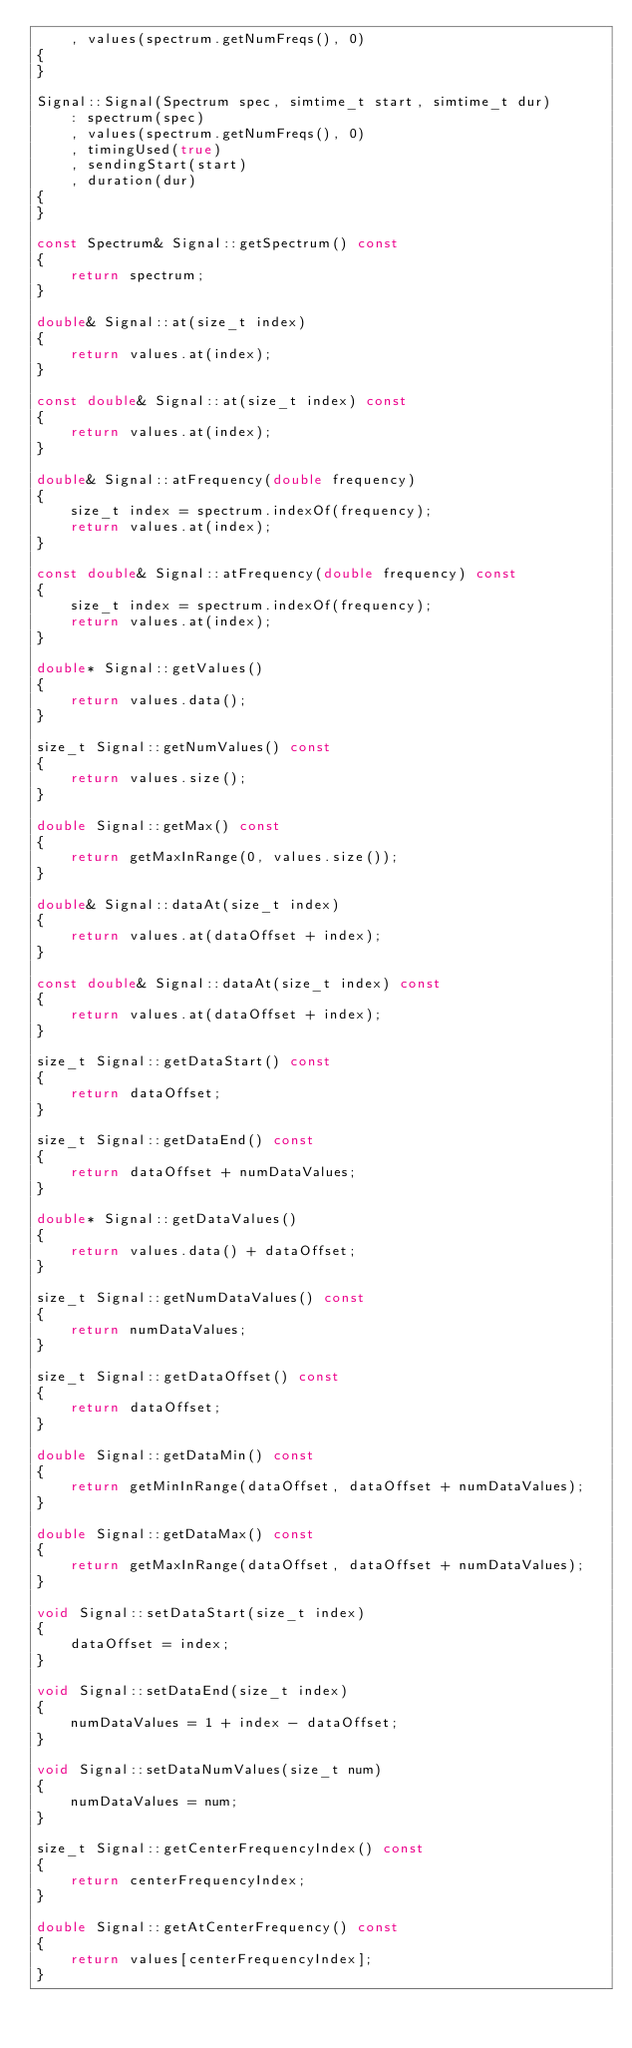Convert code to text. <code><loc_0><loc_0><loc_500><loc_500><_C++_>    , values(spectrum.getNumFreqs(), 0)
{
}

Signal::Signal(Spectrum spec, simtime_t start, simtime_t dur)
    : spectrum(spec)
    , values(spectrum.getNumFreqs(), 0)
    , timingUsed(true)
    , sendingStart(start)
    , duration(dur)
{
}

const Spectrum& Signal::getSpectrum() const
{
    return spectrum;
}

double& Signal::at(size_t index)
{
    return values.at(index);
}

const double& Signal::at(size_t index) const
{
    return values.at(index);
}

double& Signal::atFrequency(double frequency)
{
    size_t index = spectrum.indexOf(frequency);
    return values.at(index);
}

const double& Signal::atFrequency(double frequency) const
{
    size_t index = spectrum.indexOf(frequency);
    return values.at(index);
}

double* Signal::getValues()
{
    return values.data();
}

size_t Signal::getNumValues() const
{
    return values.size();
}

double Signal::getMax() const
{
    return getMaxInRange(0, values.size());
}

double& Signal::dataAt(size_t index)
{
    return values.at(dataOffset + index);
}

const double& Signal::dataAt(size_t index) const
{
    return values.at(dataOffset + index);
}

size_t Signal::getDataStart() const
{
    return dataOffset;
}

size_t Signal::getDataEnd() const
{
    return dataOffset + numDataValues;
}

double* Signal::getDataValues()
{
    return values.data() + dataOffset;
}

size_t Signal::getNumDataValues() const
{
    return numDataValues;
}

size_t Signal::getDataOffset() const
{
    return dataOffset;
}

double Signal::getDataMin() const
{
    return getMinInRange(dataOffset, dataOffset + numDataValues);
}

double Signal::getDataMax() const
{
    return getMaxInRange(dataOffset, dataOffset + numDataValues);
}

void Signal::setDataStart(size_t index)
{
    dataOffset = index;
}

void Signal::setDataEnd(size_t index)
{
    numDataValues = 1 + index - dataOffset;
}

void Signal::setDataNumValues(size_t num)
{
    numDataValues = num;
}

size_t Signal::getCenterFrequencyIndex() const
{
    return centerFrequencyIndex;
}

double Signal::getAtCenterFrequency() const
{
    return values[centerFrequencyIndex];
}
</code> 